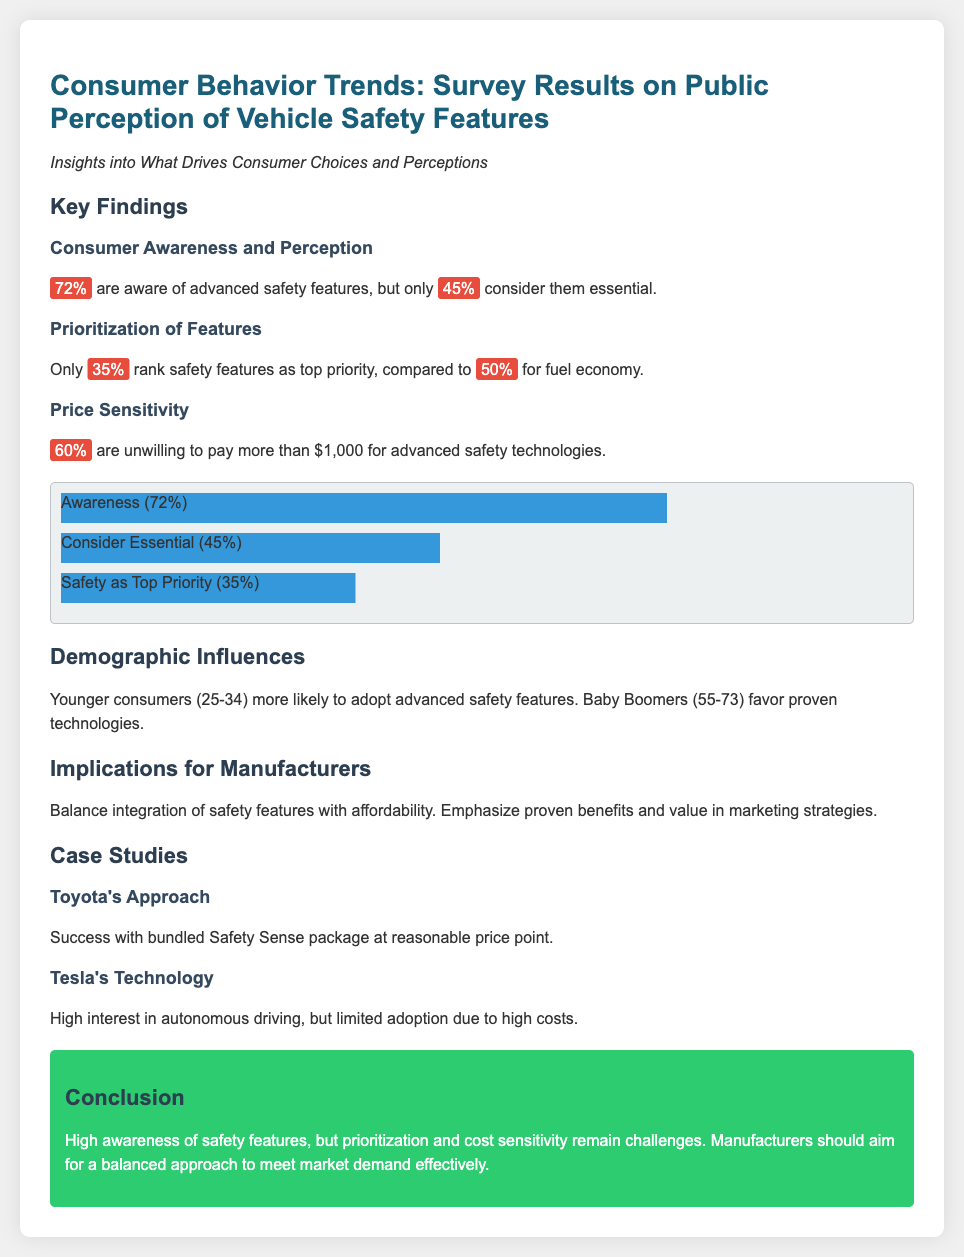What percentage of consumers are aware of advanced safety features? The document states that 72% of consumers are aware of advanced safety features.
Answer: 72% What percentage considers advanced safety features essential? The document mentions that only 45% consider them essential.
Answer: 45% What is the top priority percentage for safety features? According to the document, only 35% rank safety features as a top priority.
Answer: 35% What percentage of consumers are unwilling to pay more than $1,000 for advanced safety technologies? The document indicates that 60% are unwilling to pay more than $1,000.
Answer: 60% Which demographic group is more likely to adopt advanced safety features? The document notes that younger consumers (25-34) are more likely to adopt these features.
Answer: Younger consumers (25-34) What should manufacturers balance according to the implications section? The document states that manufacturers should balance the integration of safety features with affordability.
Answer: Integration of safety features with affordability What marketing strategy is suggested in the manufacturer implications? The document suggests emphasizing proven benefits and value in marketing strategies.
Answer: Emphasize proven benefits and value What is the name of the safety package that Toyota successfully bundled? The document mentions Toyota's Safety Sense package.
Answer: Safety Sense What is a limitation mentioned regarding Tesla's technology? The document states that there is high interest in autonomous driving but limited adoption due to high costs.
Answer: High costs 